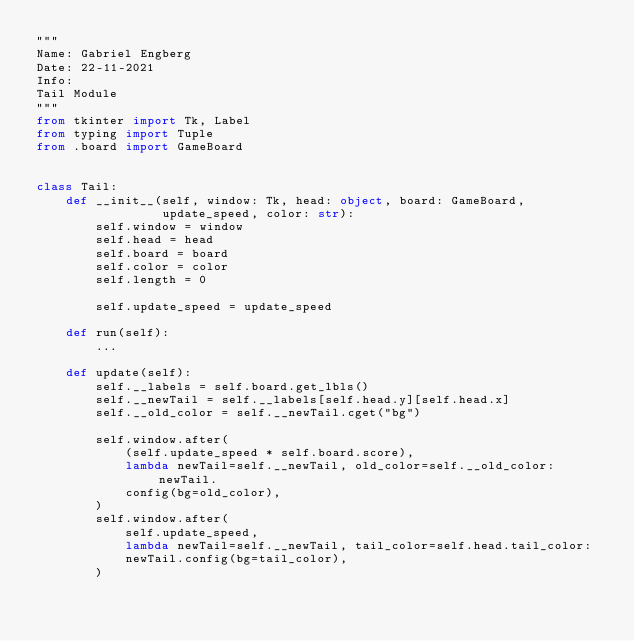<code> <loc_0><loc_0><loc_500><loc_500><_Python_>"""
Name: Gabriel Engberg
Date: 22-11-2021
Info:
Tail Module
"""
from tkinter import Tk, Label
from typing import Tuple
from .board import GameBoard


class Tail:
    def __init__(self, window: Tk, head: object, board: GameBoard,
                 update_speed, color: str):
        self.window = window
        self.head = head
        self.board = board
        self.color = color
        self.length = 0

        self.update_speed = update_speed

    def run(self):
        ...

    def update(self):
        self.__labels = self.board.get_lbls()
        self.__newTail = self.__labels[self.head.y][self.head.x]
        self.__old_color = self.__newTail.cget("bg")

        self.window.after(
            (self.update_speed * self.board.score),
            lambda newTail=self.__newTail, old_color=self.__old_color: newTail.
            config(bg=old_color),
        )
        self.window.after(
            self.update_speed,
            lambda newTail=self.__newTail, tail_color=self.head.tail_color:
            newTail.config(bg=tail_color),
        )
</code> 